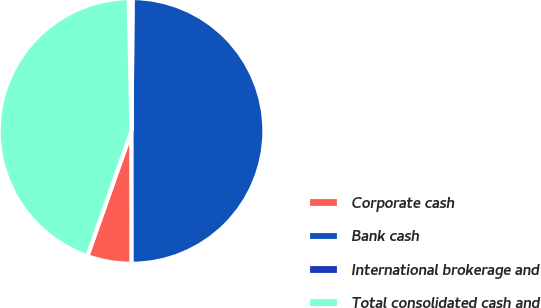Convert chart to OTSL. <chart><loc_0><loc_0><loc_500><loc_500><pie_chart><fcel>Corporate cash<fcel>Bank cash<fcel>International brokerage and<fcel>Total consolidated cash and<nl><fcel>5.41%<fcel>49.86%<fcel>0.47%<fcel>44.26%<nl></chart> 